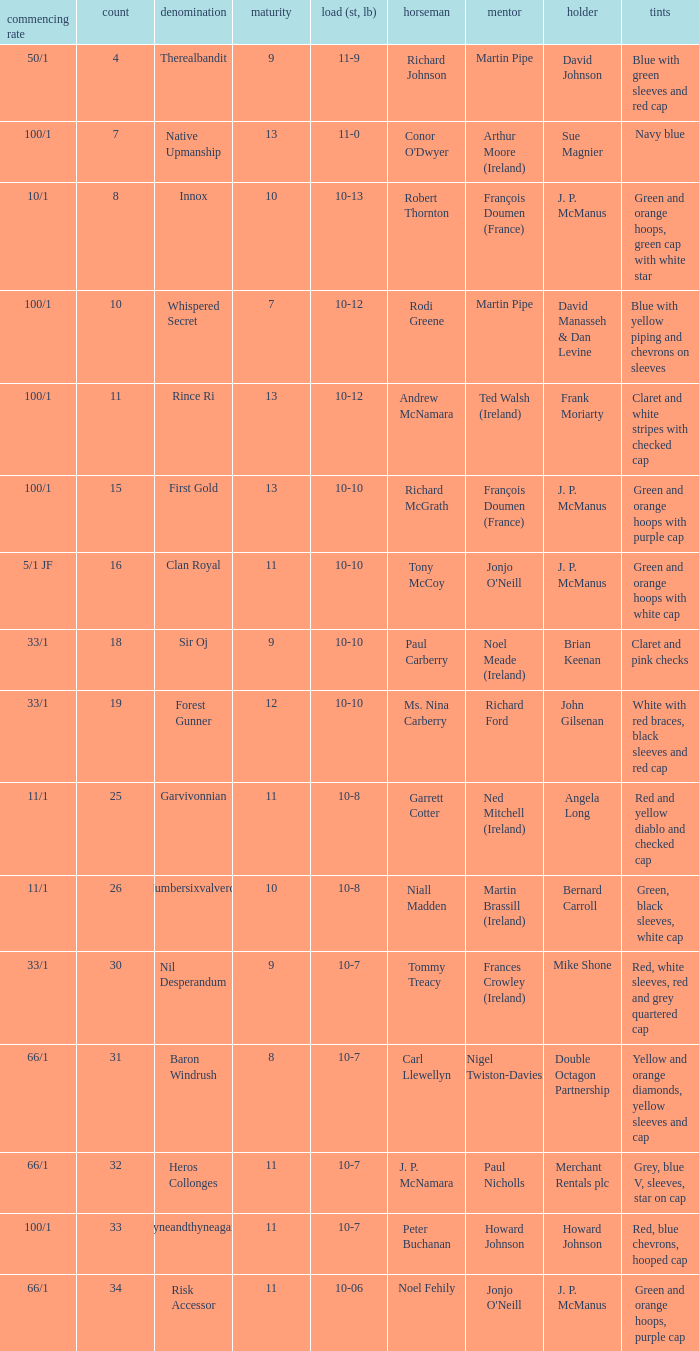How many age entries had a weight of 10-7 and an owner of Double Octagon Partnership? 1.0. 